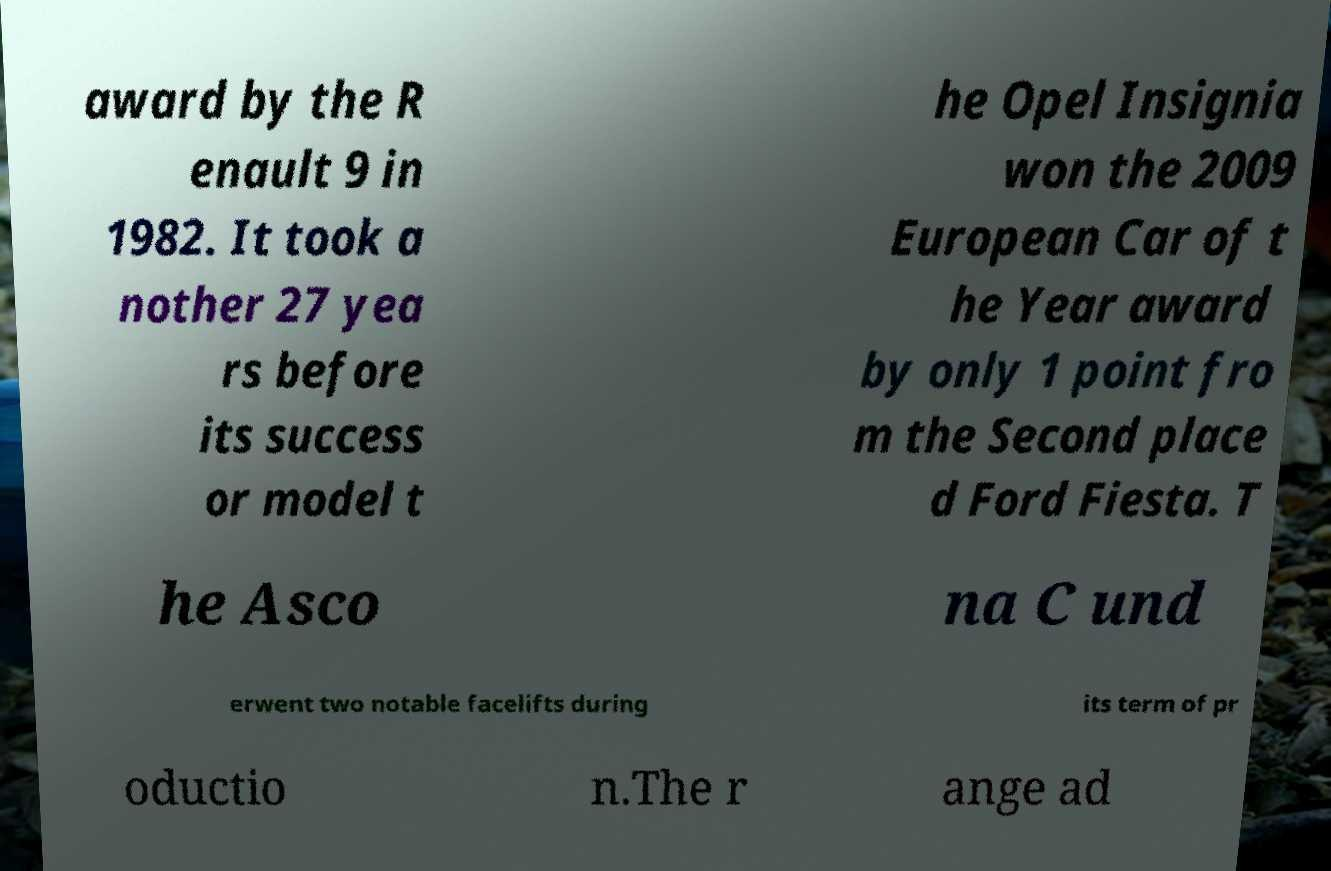For documentation purposes, I need the text within this image transcribed. Could you provide that? award by the R enault 9 in 1982. It took a nother 27 yea rs before its success or model t he Opel Insignia won the 2009 European Car of t he Year award by only 1 point fro m the Second place d Ford Fiesta. T he Asco na C und erwent two notable facelifts during its term of pr oductio n.The r ange ad 